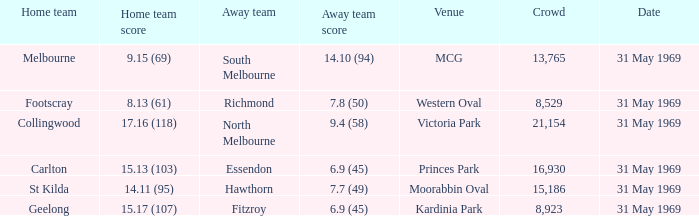Who was the home team that played in Victoria Park? Collingwood. 